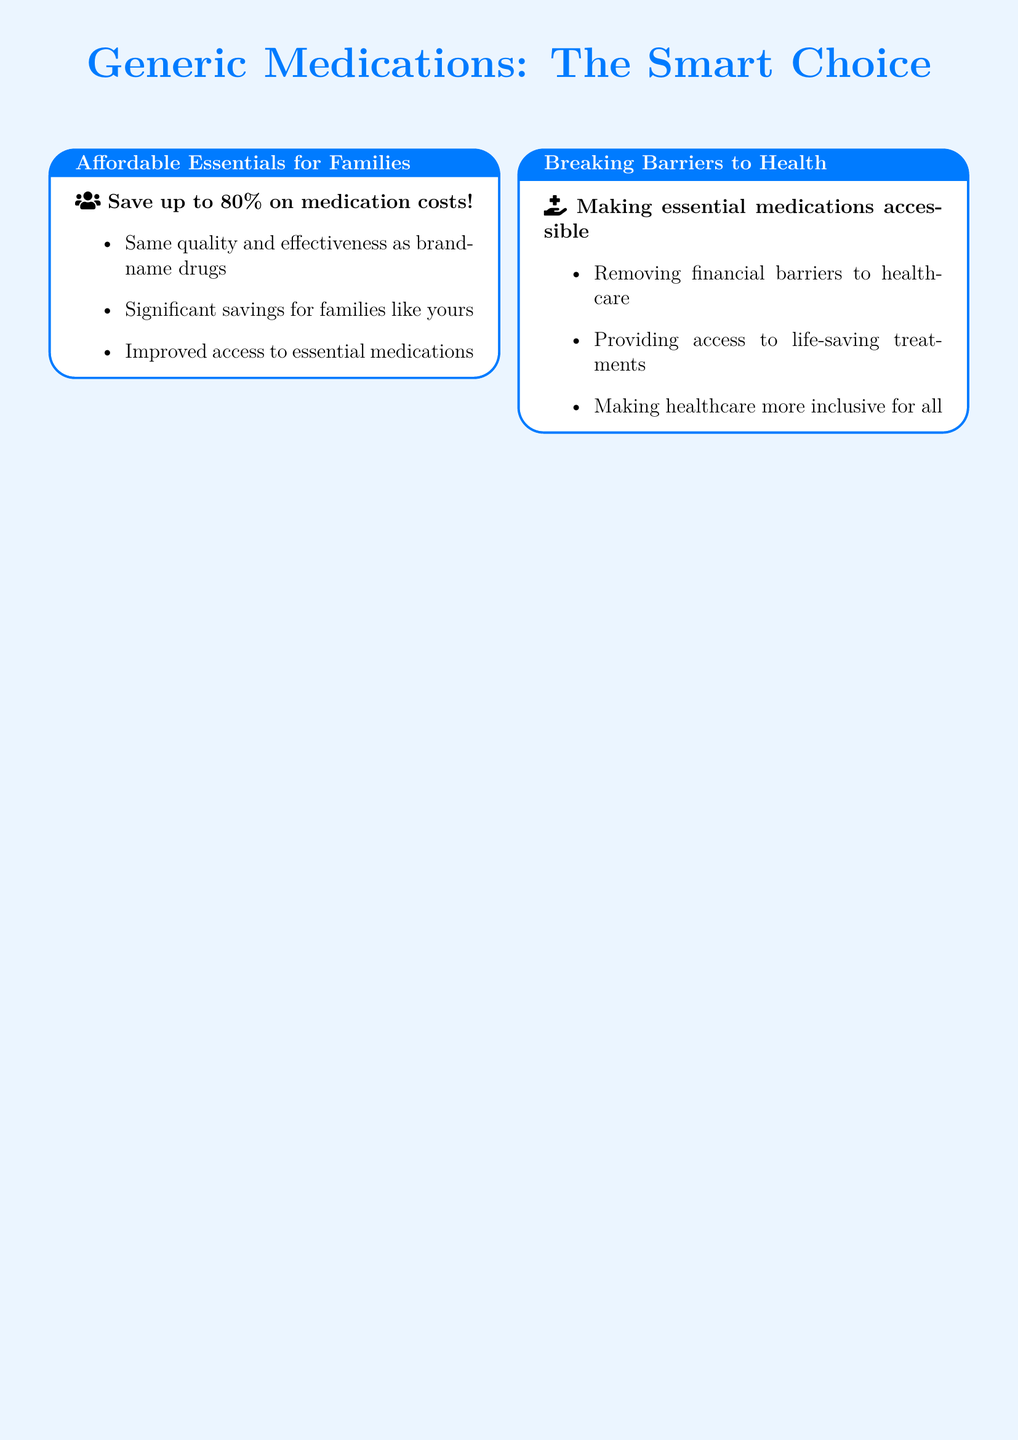What is the maximum percentage you can save on medication costs? The document mentions that you can save up to 80% on medication costs.
Answer: 80% What type of standards do generic drugs meet? It is stated that generic drugs meet rigorous FDA-approved standards.
Answer: FDA-approved standards Who is the pharmacist quoted in the document? The quote attributed to a pharmacist is from Dr. Samantha Lee, Pharm.D.
Answer: Dr. Samantha Lee What is emphasized alongside health benefits in patient testimonials? The document highlights both health and budget improvements in patient testimonials.
Answer: Budget What is the main benefit of choosing generic drugs according to the pharmacist? The pharmacist states that generics offer the same therapeutic benefits as brand-name drugs.
Answer: Same therapeutic benefits What do generic medications improve for families? The advertisement focuses on significant savings for families with generic medications.
Answer: Savings What visual representation is used in the 'Breaking Barriers to Health' section? This section uses impactful visuals of barrier-breaking icons or metaphors.
Answer: Barrier-breaking icons What category does the advertisement focus on with smiling faces? The ad highlights affordable essentials with a family-oriented design and smiling faces.
Answer: Affordable essentials What is one action encouraged in the document? The document encourages consulting your pharmacist today for advice on generics.
Answer: Consult your pharmacist 